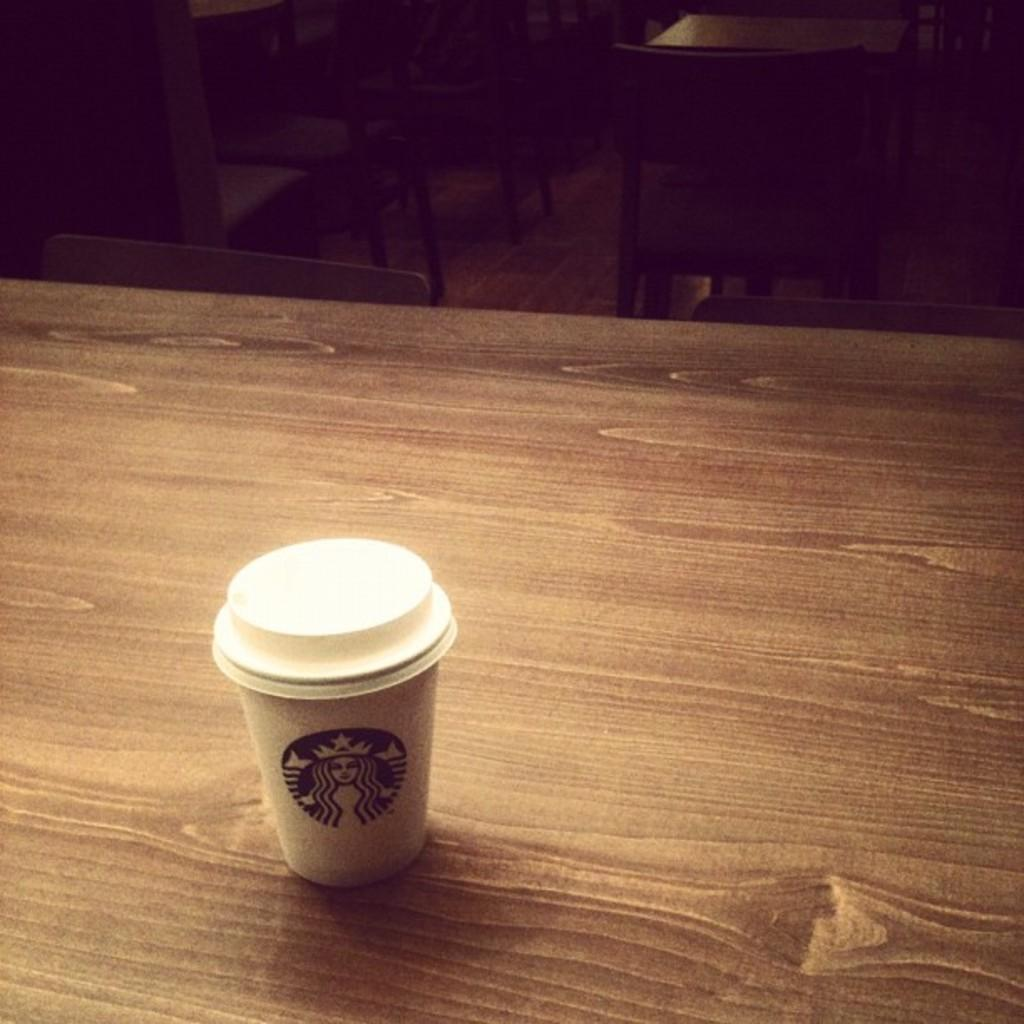What piece of furniture is at the bottom of the image? There is a table at the bottom of the image. What is placed on the table? There is a cup on the table. What can be seen in the background of the image? There are chairs in the background of the image. How many giants are present in the image? There are no giants present in the image. What type of stitch is used to hold the chairs together in the image? There is no information about the chairs' construction or stitching in the image. 